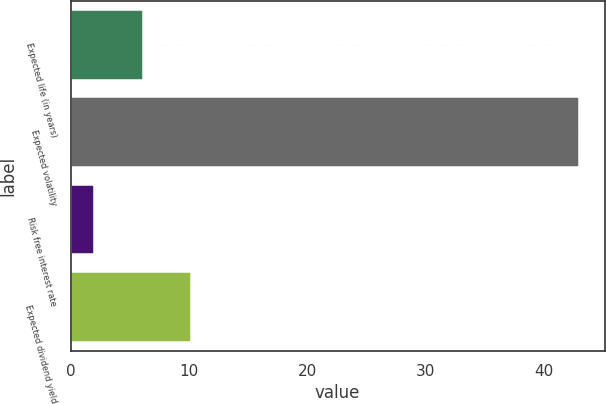Convert chart. <chart><loc_0><loc_0><loc_500><loc_500><bar_chart><fcel>Expected life (in years)<fcel>Expected volatility<fcel>Risk free interest rate<fcel>Expected dividend yield<nl><fcel>6.1<fcel>43<fcel>2<fcel>10.2<nl></chart> 